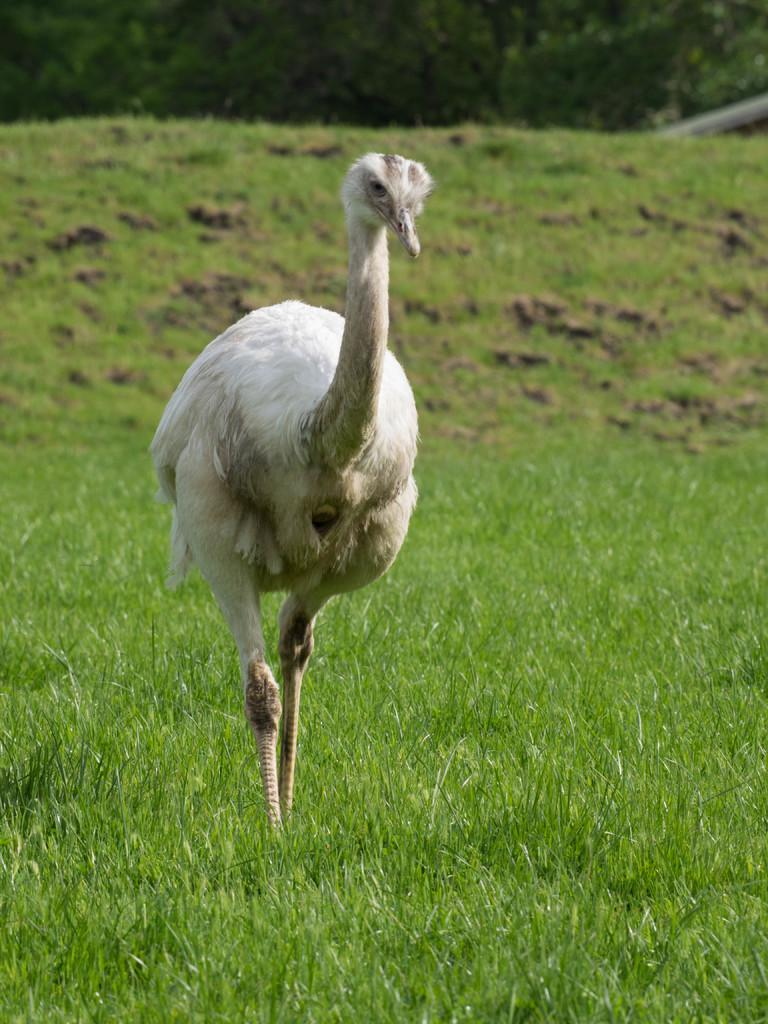What type of animal is in the picture? There is an emu bird in the picture. What is at the bottom of the picture? There is grass at the bottom of the picture. What type of cub can be seen playing with a jewel at the party in the image? There is no cub, jewel, or party present in the image; it features an emu bird and grass. 